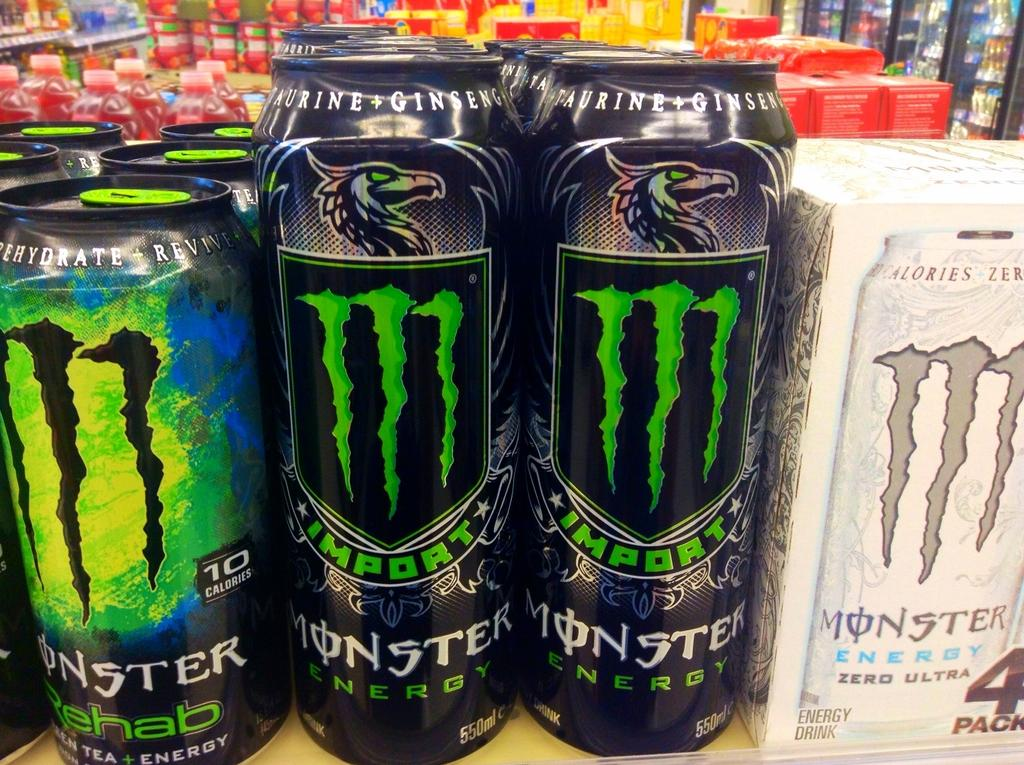<image>
Write a terse but informative summary of the picture. A display of Monster Energy drink singles and a 4 pack beside them. 